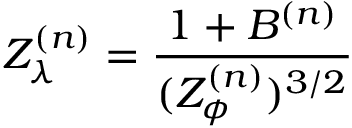Convert formula to latex. <formula><loc_0><loc_0><loc_500><loc_500>Z _ { \lambda } ^ { ( n ) } = \frac { 1 + B ^ { ( n ) } } { ( Z _ { \phi } ^ { ( n ) } ) ^ { 3 / 2 } }</formula> 